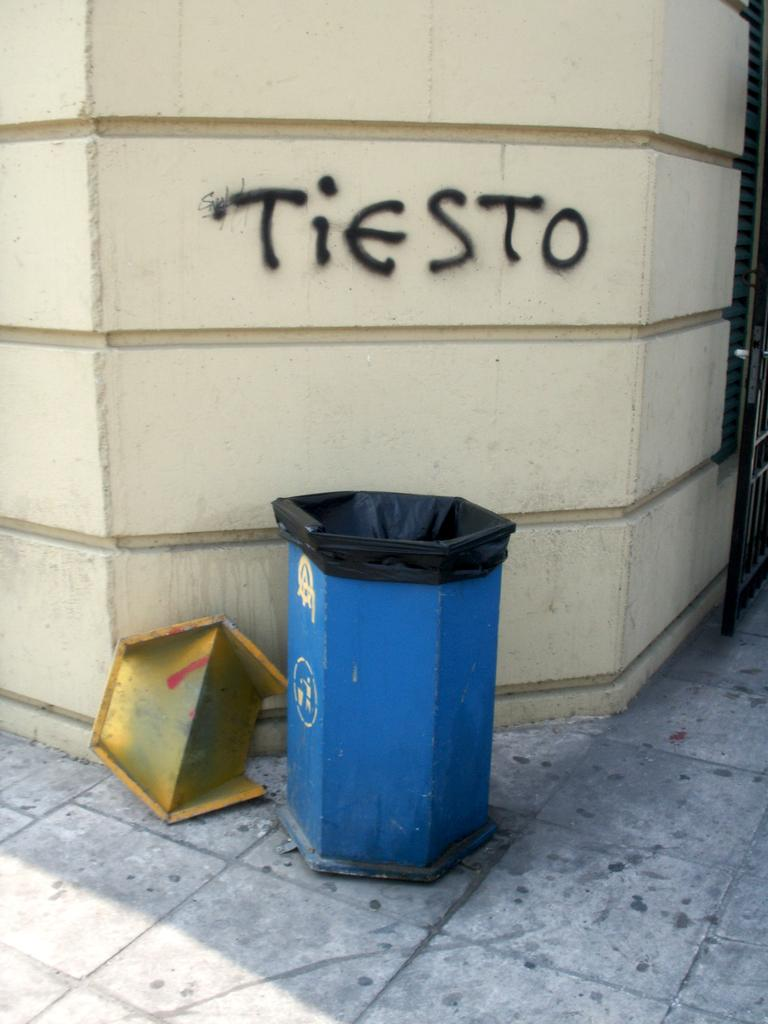<image>
Provide a brief description of the given image. The word Tiesto is spray painted on a wall above a garbage can line with black plastic. 